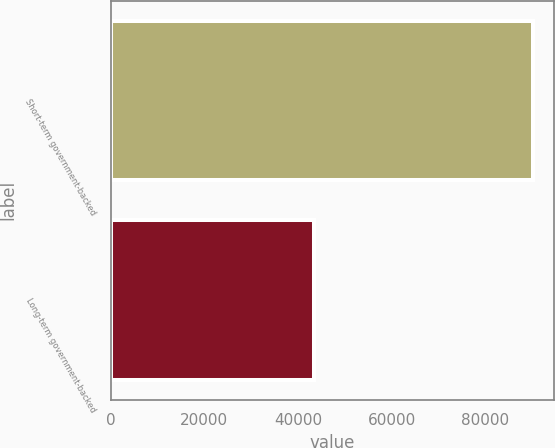<chart> <loc_0><loc_0><loc_500><loc_500><bar_chart><fcel>Short-term government-backed<fcel>Long-term government-backed<nl><fcel>90199<fcel>43484<nl></chart> 